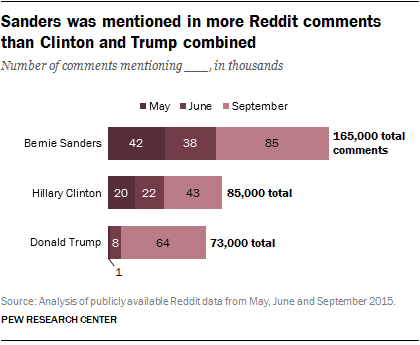Outline some significant characteristics in this image. In September, there were approximately 64,000 comments that mentioned Donald Trump. The ratio of the second smallest bar and the second largest bar is approximately 0.877777778. 